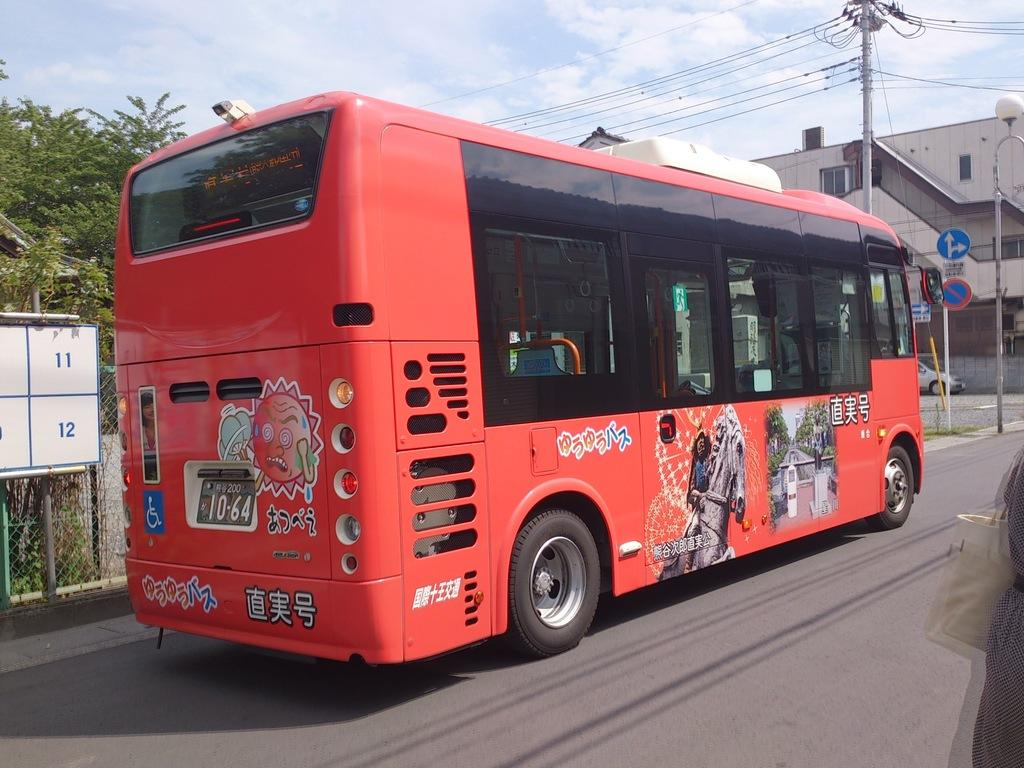What is the main subject in the center of the image? There is a bus in the center of the image. Where is the bus located? The bus is on the road. What can be seen in the background of the image? There are poles, buildings, trees, a board, and the sky visible in the background of the image. Can you see any ghosts sitting on the bus in the image? There are no ghosts visible in the image; it only shows a bus on the road and various elements in the background. 